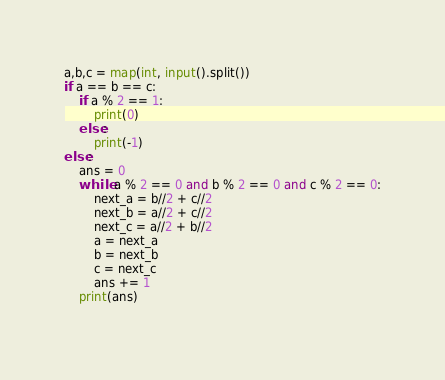<code> <loc_0><loc_0><loc_500><loc_500><_Python_>a,b,c = map(int, input().split())
if a == b == c:
    if a % 2 == 1:
        print(0)
    else:
        print(-1)
else:
    ans = 0
    while a % 2 == 0 and b % 2 == 0 and c % 2 == 0:
        next_a = b//2 + c//2
        next_b = a//2 + c//2
        next_c = a//2 + b//2
        a = next_a
        b = next_b
        c = next_c
        ans += 1
    print(ans)
    </code> 